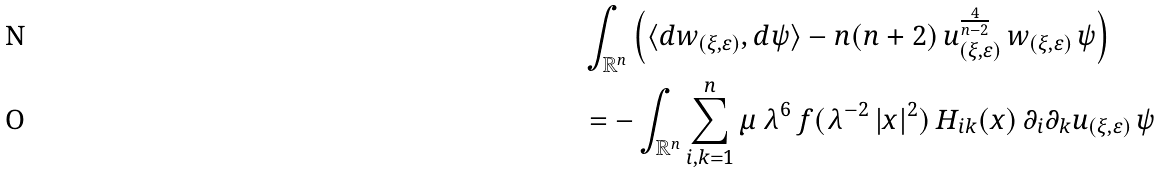Convert formula to latex. <formula><loc_0><loc_0><loc_500><loc_500>& \int _ { \mathbb { R } ^ { n } } \left ( \langle d w _ { ( \xi , \varepsilon ) } , d \psi \rangle - n ( n + 2 ) \, u _ { ( \xi , \varepsilon ) } ^ { \frac { 4 } { n - 2 } } \, w _ { ( \xi , \varepsilon ) } \, \psi \right ) \\ & = - \int _ { \mathbb { R } ^ { n } } \sum _ { i , k = 1 } ^ { n } \mu \, \lambda ^ { 6 } \, f ( \lambda ^ { - 2 } \, | x | ^ { 2 } ) \, H _ { i k } ( x ) \, \partial _ { i } \partial _ { k } u _ { ( \xi , \varepsilon ) } \, \psi</formula> 